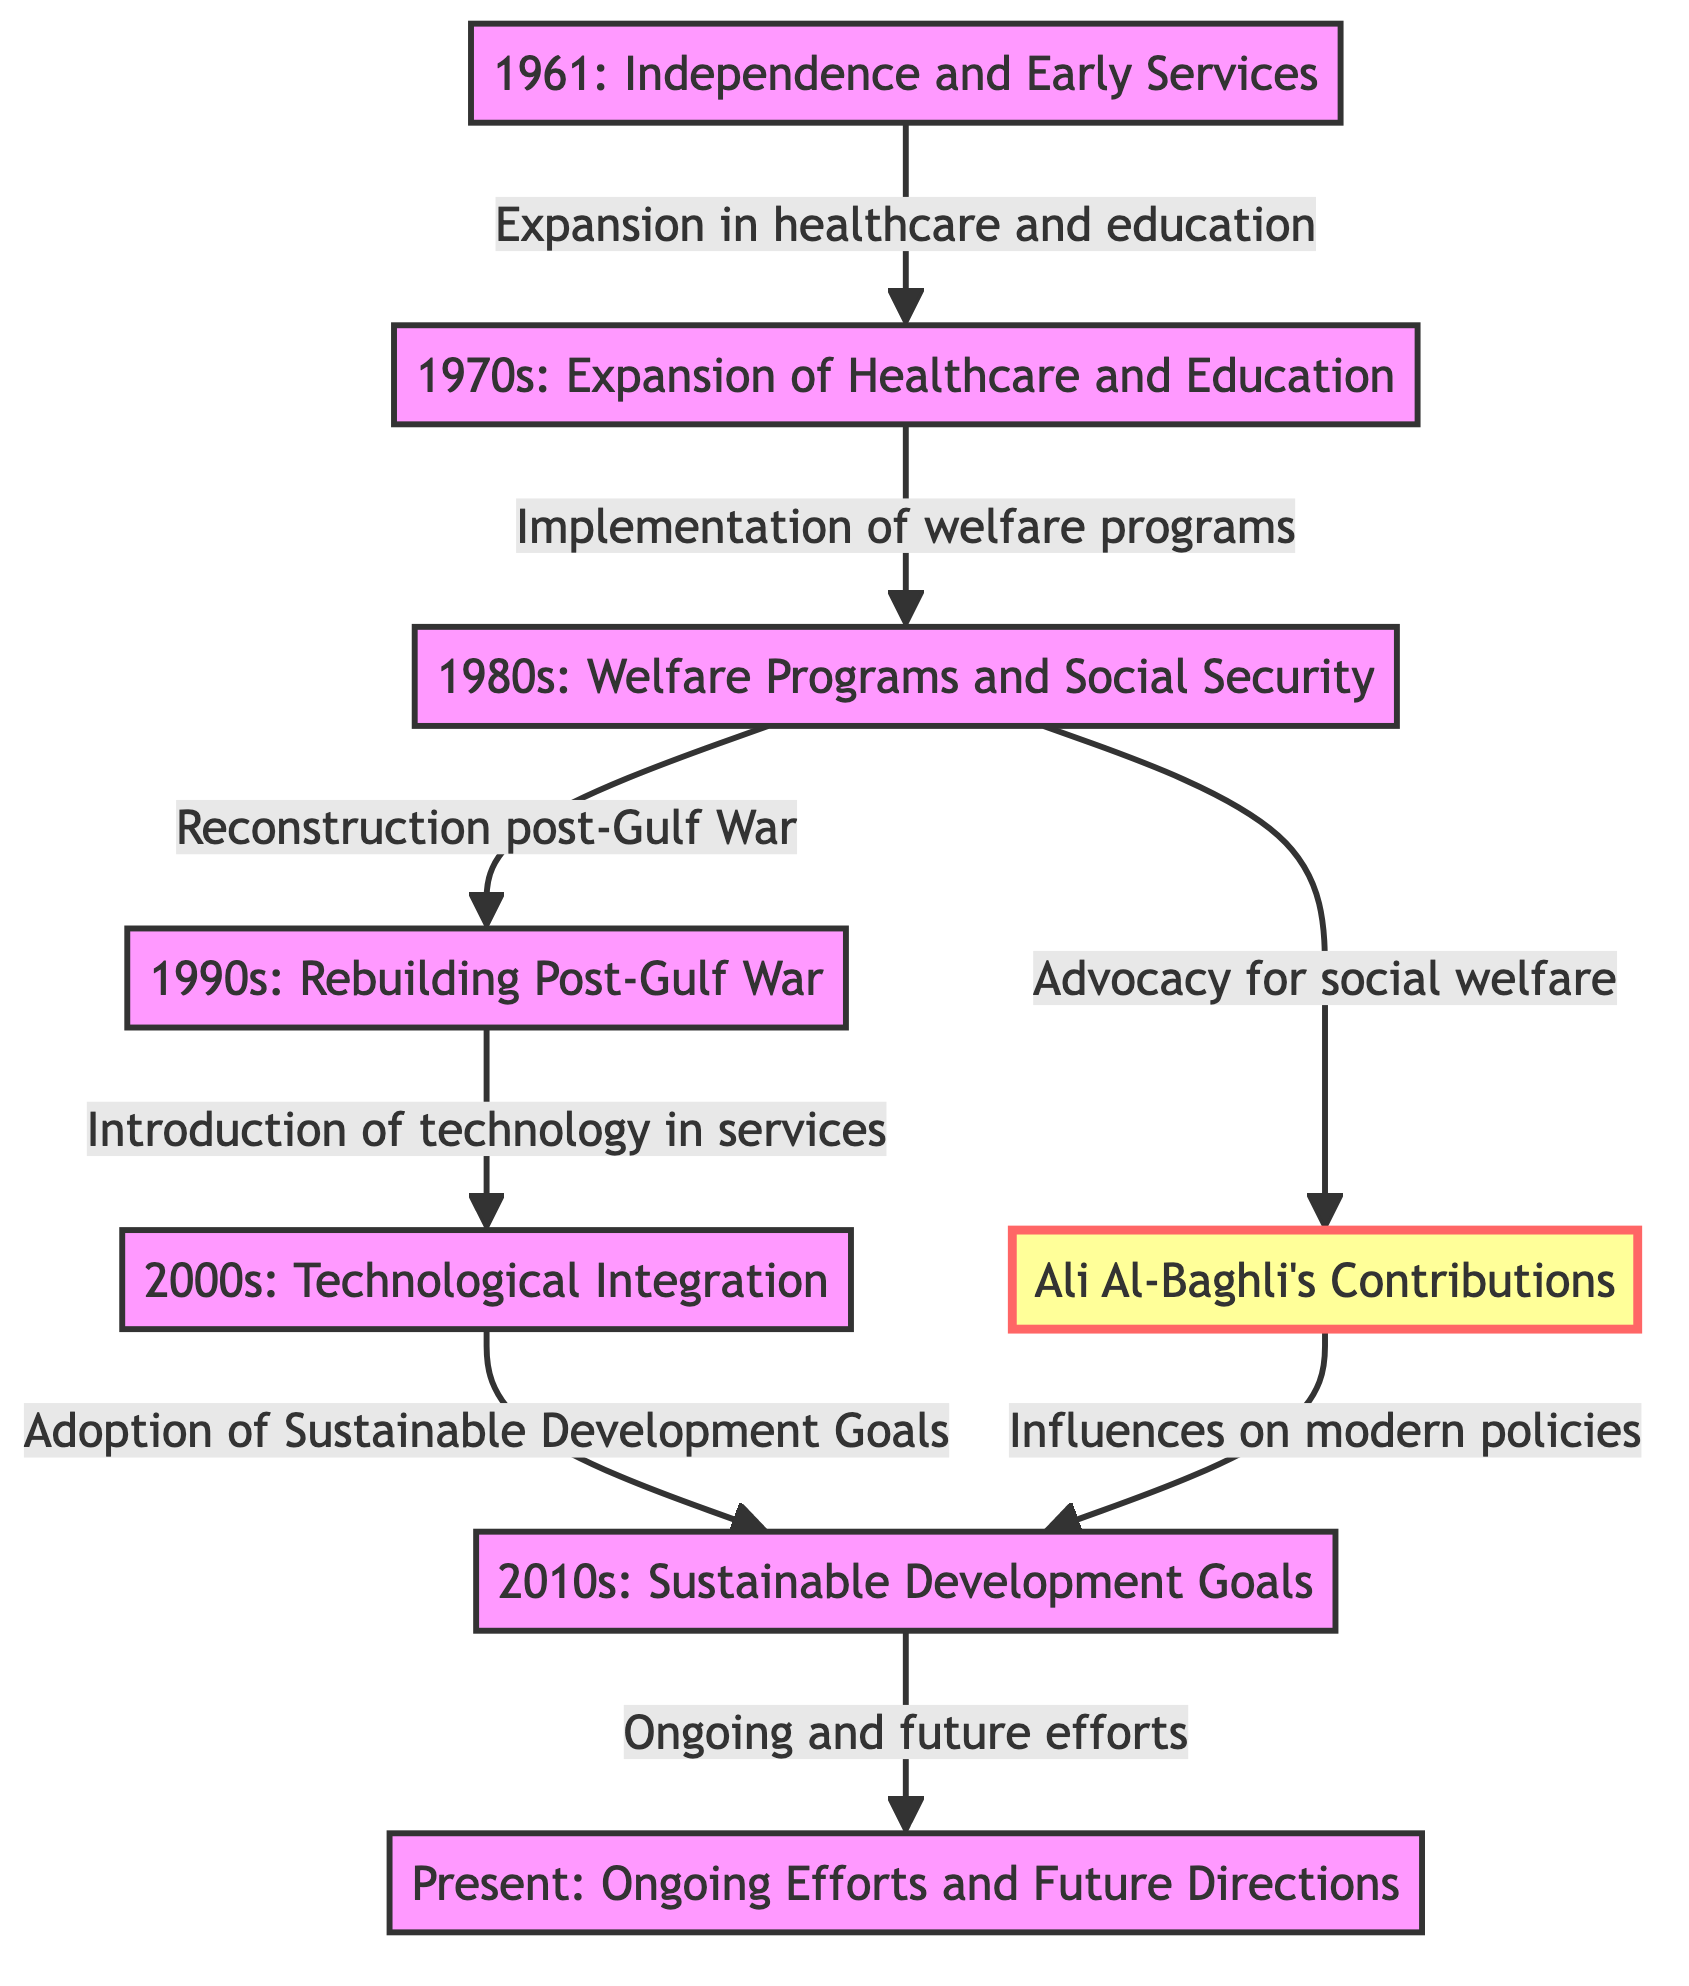What year marked the independence of Kuwait? The diagram indicates that Kuwait gained independence in 1961, which is explicitly stated in the node labeled "1961: Independence and Early Services."
Answer: 1961 What initiative is highlighted in the 1970s? According to the diagram, the connection from the node "1961: Independence and Early Services" to "1970s: Expansion of Healthcare and Education" indicates that the initiative was an expansion of healthcare and education during that decade.
Answer: Expansion of Healthcare and Education Which decade focused on welfare programs and social security? The diagram shows a direct link from the 1970s node to the 1980s node, which is labeled as "1980s: Welfare Programs and Social Security," thereby indicating this focus.
Answer: 1980s Name one of the contributions of Ali Al-Baghli according to the diagram. The diagram presents a specific note that "1980s: Advocacy for social welfare" is linked to Ali Al-Baghli's contributions, indicating his role in promoting social welfare during that time.
Answer: Advocacy for social welfare What technological advancement occurred in the 2000s? The transition from the 1990s node to the 2000s node mentions "Introduction of technology in services," indicating that this technological advancement was a key focus during the 2000s.
Answer: Introduction of technology in services How are the 2010s related to sustainable goals? The flow from the 2000s to the 2010s connects the "Adoption of Sustainable Development Goals" to the decade of 2010s, explicitly stating its relationship and focus during that period.
Answer: Adoption of Sustainable Development Goals What is one influence of Ali Al-Baghli on modern policies? The diagram connects Ali Al-Baghli’s contributions to the 2010s, marked as "Influences on modern policies," thereby showing how his advocacy impacted policy development.
Answer: Influences on modern policies How many key decades are represented in the diagram? The nodes labeled from 1961 to the Present highlight six distinct decades: 1961, 1970s, 1980s, 1990s, 2000s, and 2010s, including the Present, yielding a total of seven key timeframes.
Answer: 7 What type of development is indicated as ongoing in the Present? The diagram points out that the flow from "2010s: Sustainable Development Goals" leads to "Present: Ongoing Efforts and Future Directions," indicating a continuation of development efforts.
Answer: Ongoing Efforts and Future Directions 